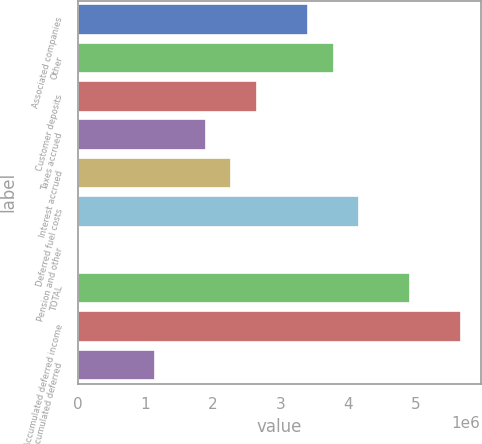<chart> <loc_0><loc_0><loc_500><loc_500><bar_chart><fcel>Associated companies<fcel>Other<fcel>Customer deposits<fcel>Taxes accrued<fcel>Interest accrued<fcel>Deferred fuel costs<fcel>Pension and other<fcel>TOTAL<fcel>Accumulated deferred income<fcel>Accumulated deferred<nl><fcel>3.40561e+06<fcel>3.78386e+06<fcel>2.64911e+06<fcel>1.89261e+06<fcel>2.27086e+06<fcel>4.16212e+06<fcel>1354<fcel>4.91862e+06<fcel>5.67512e+06<fcel>1.13611e+06<nl></chart> 